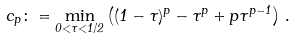<formula> <loc_0><loc_0><loc_500><loc_500>c _ { p } \colon = \min _ { 0 < \tau < 1 / 2 } \left ( ( 1 - \tau ) ^ { p } - \tau ^ { p } + p \tau ^ { p - 1 } \right ) \, .</formula> 